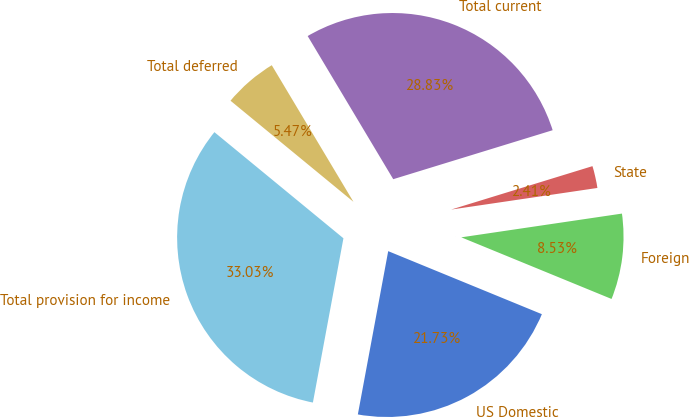<chart> <loc_0><loc_0><loc_500><loc_500><pie_chart><fcel>US Domestic<fcel>Foreign<fcel>State<fcel>Total current<fcel>Total deferred<fcel>Total provision for income<nl><fcel>21.73%<fcel>8.53%<fcel>2.41%<fcel>28.83%<fcel>5.47%<fcel>33.03%<nl></chart> 